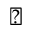<formula> <loc_0><loc_0><loc_500><loc_500>\triangle d o w n</formula> 